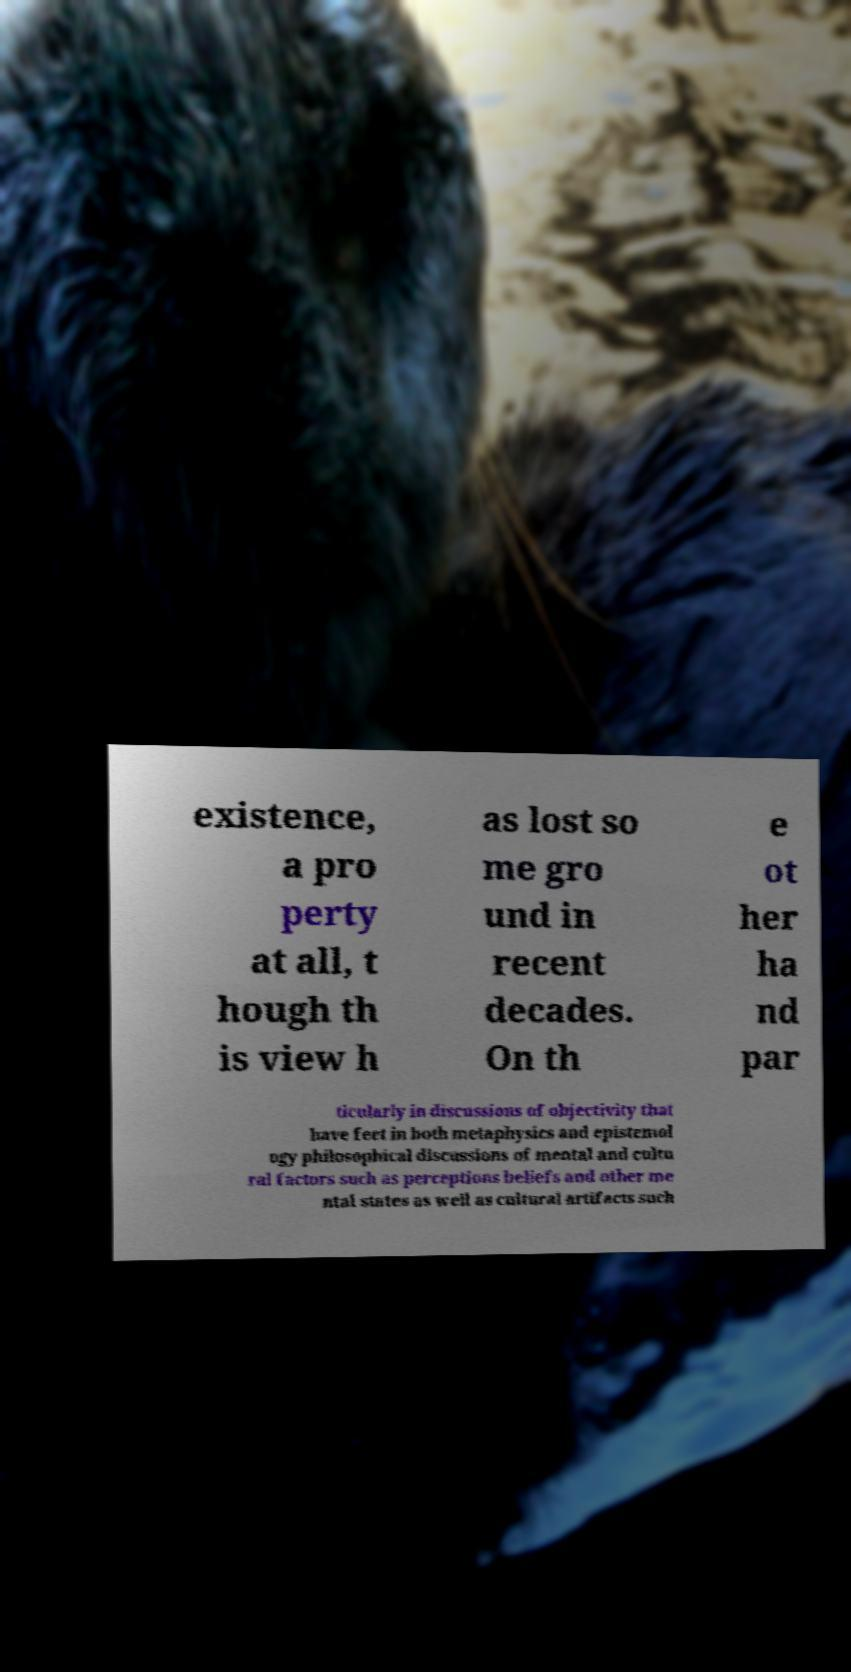Can you read and provide the text displayed in the image?This photo seems to have some interesting text. Can you extract and type it out for me? existence, a pro perty at all, t hough th is view h as lost so me gro und in recent decades. On th e ot her ha nd par ticularly in discussions of objectivity that have feet in both metaphysics and epistemol ogy philosophical discussions of mental and cultu ral factors such as perceptions beliefs and other me ntal states as well as cultural artifacts such 